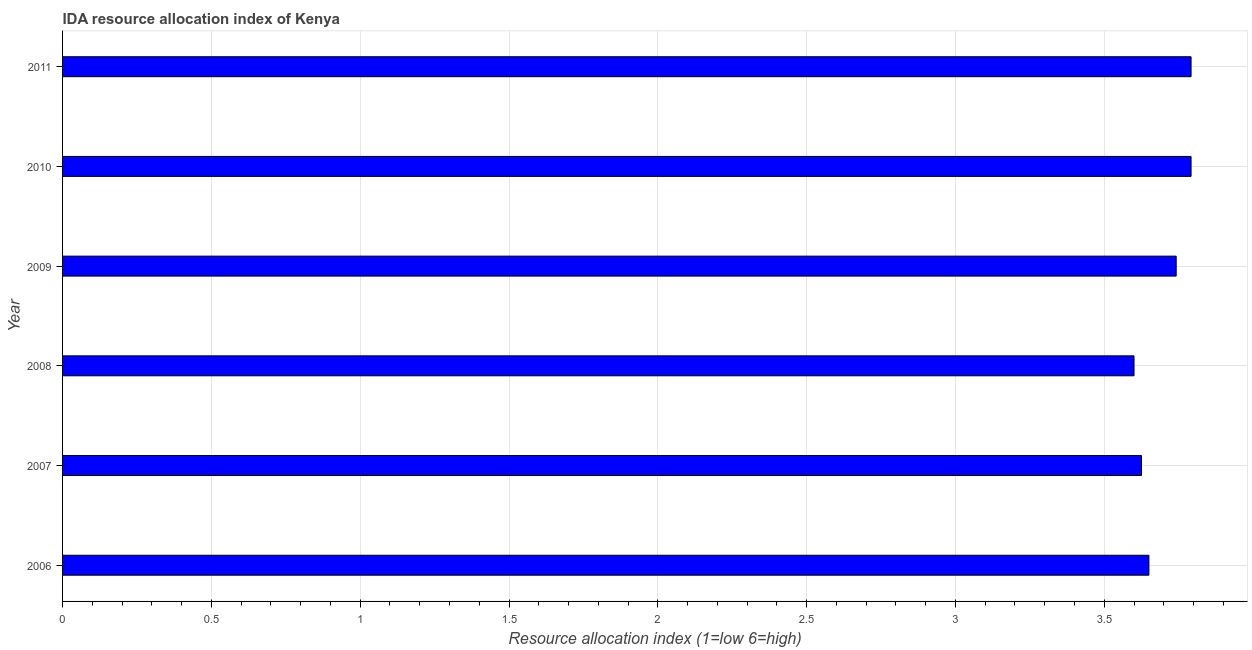Does the graph contain grids?
Offer a terse response. Yes. What is the title of the graph?
Your response must be concise. IDA resource allocation index of Kenya. What is the label or title of the X-axis?
Provide a succinct answer. Resource allocation index (1=low 6=high). What is the label or title of the Y-axis?
Make the answer very short. Year. What is the ida resource allocation index in 2006?
Provide a succinct answer. 3.65. Across all years, what is the maximum ida resource allocation index?
Ensure brevity in your answer.  3.79. Across all years, what is the minimum ida resource allocation index?
Your response must be concise. 3.6. What is the sum of the ida resource allocation index?
Provide a succinct answer. 22.2. What is the difference between the ida resource allocation index in 2008 and 2009?
Provide a succinct answer. -0.14. What is the median ida resource allocation index?
Your answer should be compact. 3.7. In how many years, is the ida resource allocation index greater than 0.9 ?
Provide a short and direct response. 6. Do a majority of the years between 2011 and 2010 (inclusive) have ida resource allocation index greater than 1.8 ?
Your answer should be very brief. No. What is the ratio of the ida resource allocation index in 2008 to that in 2011?
Provide a succinct answer. 0.95. Is the ida resource allocation index in 2006 less than that in 2009?
Your response must be concise. Yes. What is the difference between the highest and the second highest ida resource allocation index?
Make the answer very short. 0. What is the difference between the highest and the lowest ida resource allocation index?
Provide a short and direct response. 0.19. Are the values on the major ticks of X-axis written in scientific E-notation?
Keep it short and to the point. No. What is the Resource allocation index (1=low 6=high) in 2006?
Offer a very short reply. 3.65. What is the Resource allocation index (1=low 6=high) of 2007?
Offer a terse response. 3.62. What is the Resource allocation index (1=low 6=high) in 2008?
Your response must be concise. 3.6. What is the Resource allocation index (1=low 6=high) of 2009?
Keep it short and to the point. 3.74. What is the Resource allocation index (1=low 6=high) of 2010?
Give a very brief answer. 3.79. What is the Resource allocation index (1=low 6=high) of 2011?
Your answer should be compact. 3.79. What is the difference between the Resource allocation index (1=low 6=high) in 2006 and 2007?
Your answer should be very brief. 0.03. What is the difference between the Resource allocation index (1=low 6=high) in 2006 and 2008?
Provide a succinct answer. 0.05. What is the difference between the Resource allocation index (1=low 6=high) in 2006 and 2009?
Offer a terse response. -0.09. What is the difference between the Resource allocation index (1=low 6=high) in 2006 and 2010?
Provide a short and direct response. -0.14. What is the difference between the Resource allocation index (1=low 6=high) in 2006 and 2011?
Offer a terse response. -0.14. What is the difference between the Resource allocation index (1=low 6=high) in 2007 and 2008?
Provide a short and direct response. 0.03. What is the difference between the Resource allocation index (1=low 6=high) in 2007 and 2009?
Make the answer very short. -0.12. What is the difference between the Resource allocation index (1=low 6=high) in 2007 and 2010?
Give a very brief answer. -0.17. What is the difference between the Resource allocation index (1=low 6=high) in 2007 and 2011?
Offer a very short reply. -0.17. What is the difference between the Resource allocation index (1=low 6=high) in 2008 and 2009?
Your answer should be very brief. -0.14. What is the difference between the Resource allocation index (1=low 6=high) in 2008 and 2010?
Ensure brevity in your answer.  -0.19. What is the difference between the Resource allocation index (1=low 6=high) in 2008 and 2011?
Give a very brief answer. -0.19. What is the difference between the Resource allocation index (1=low 6=high) in 2009 and 2010?
Offer a very short reply. -0.05. What is the difference between the Resource allocation index (1=low 6=high) in 2009 and 2011?
Your answer should be compact. -0.05. What is the ratio of the Resource allocation index (1=low 6=high) in 2006 to that in 2007?
Provide a short and direct response. 1.01. What is the ratio of the Resource allocation index (1=low 6=high) in 2006 to that in 2010?
Ensure brevity in your answer.  0.96. What is the ratio of the Resource allocation index (1=low 6=high) in 2006 to that in 2011?
Your answer should be very brief. 0.96. What is the ratio of the Resource allocation index (1=low 6=high) in 2007 to that in 2009?
Provide a short and direct response. 0.97. What is the ratio of the Resource allocation index (1=low 6=high) in 2007 to that in 2010?
Your answer should be very brief. 0.96. What is the ratio of the Resource allocation index (1=low 6=high) in 2007 to that in 2011?
Offer a terse response. 0.96. What is the ratio of the Resource allocation index (1=low 6=high) in 2008 to that in 2009?
Your answer should be very brief. 0.96. What is the ratio of the Resource allocation index (1=low 6=high) in 2008 to that in 2010?
Your answer should be very brief. 0.95. What is the ratio of the Resource allocation index (1=low 6=high) in 2008 to that in 2011?
Provide a short and direct response. 0.95. What is the ratio of the Resource allocation index (1=low 6=high) in 2009 to that in 2010?
Provide a succinct answer. 0.99. What is the ratio of the Resource allocation index (1=low 6=high) in 2010 to that in 2011?
Your answer should be very brief. 1. 